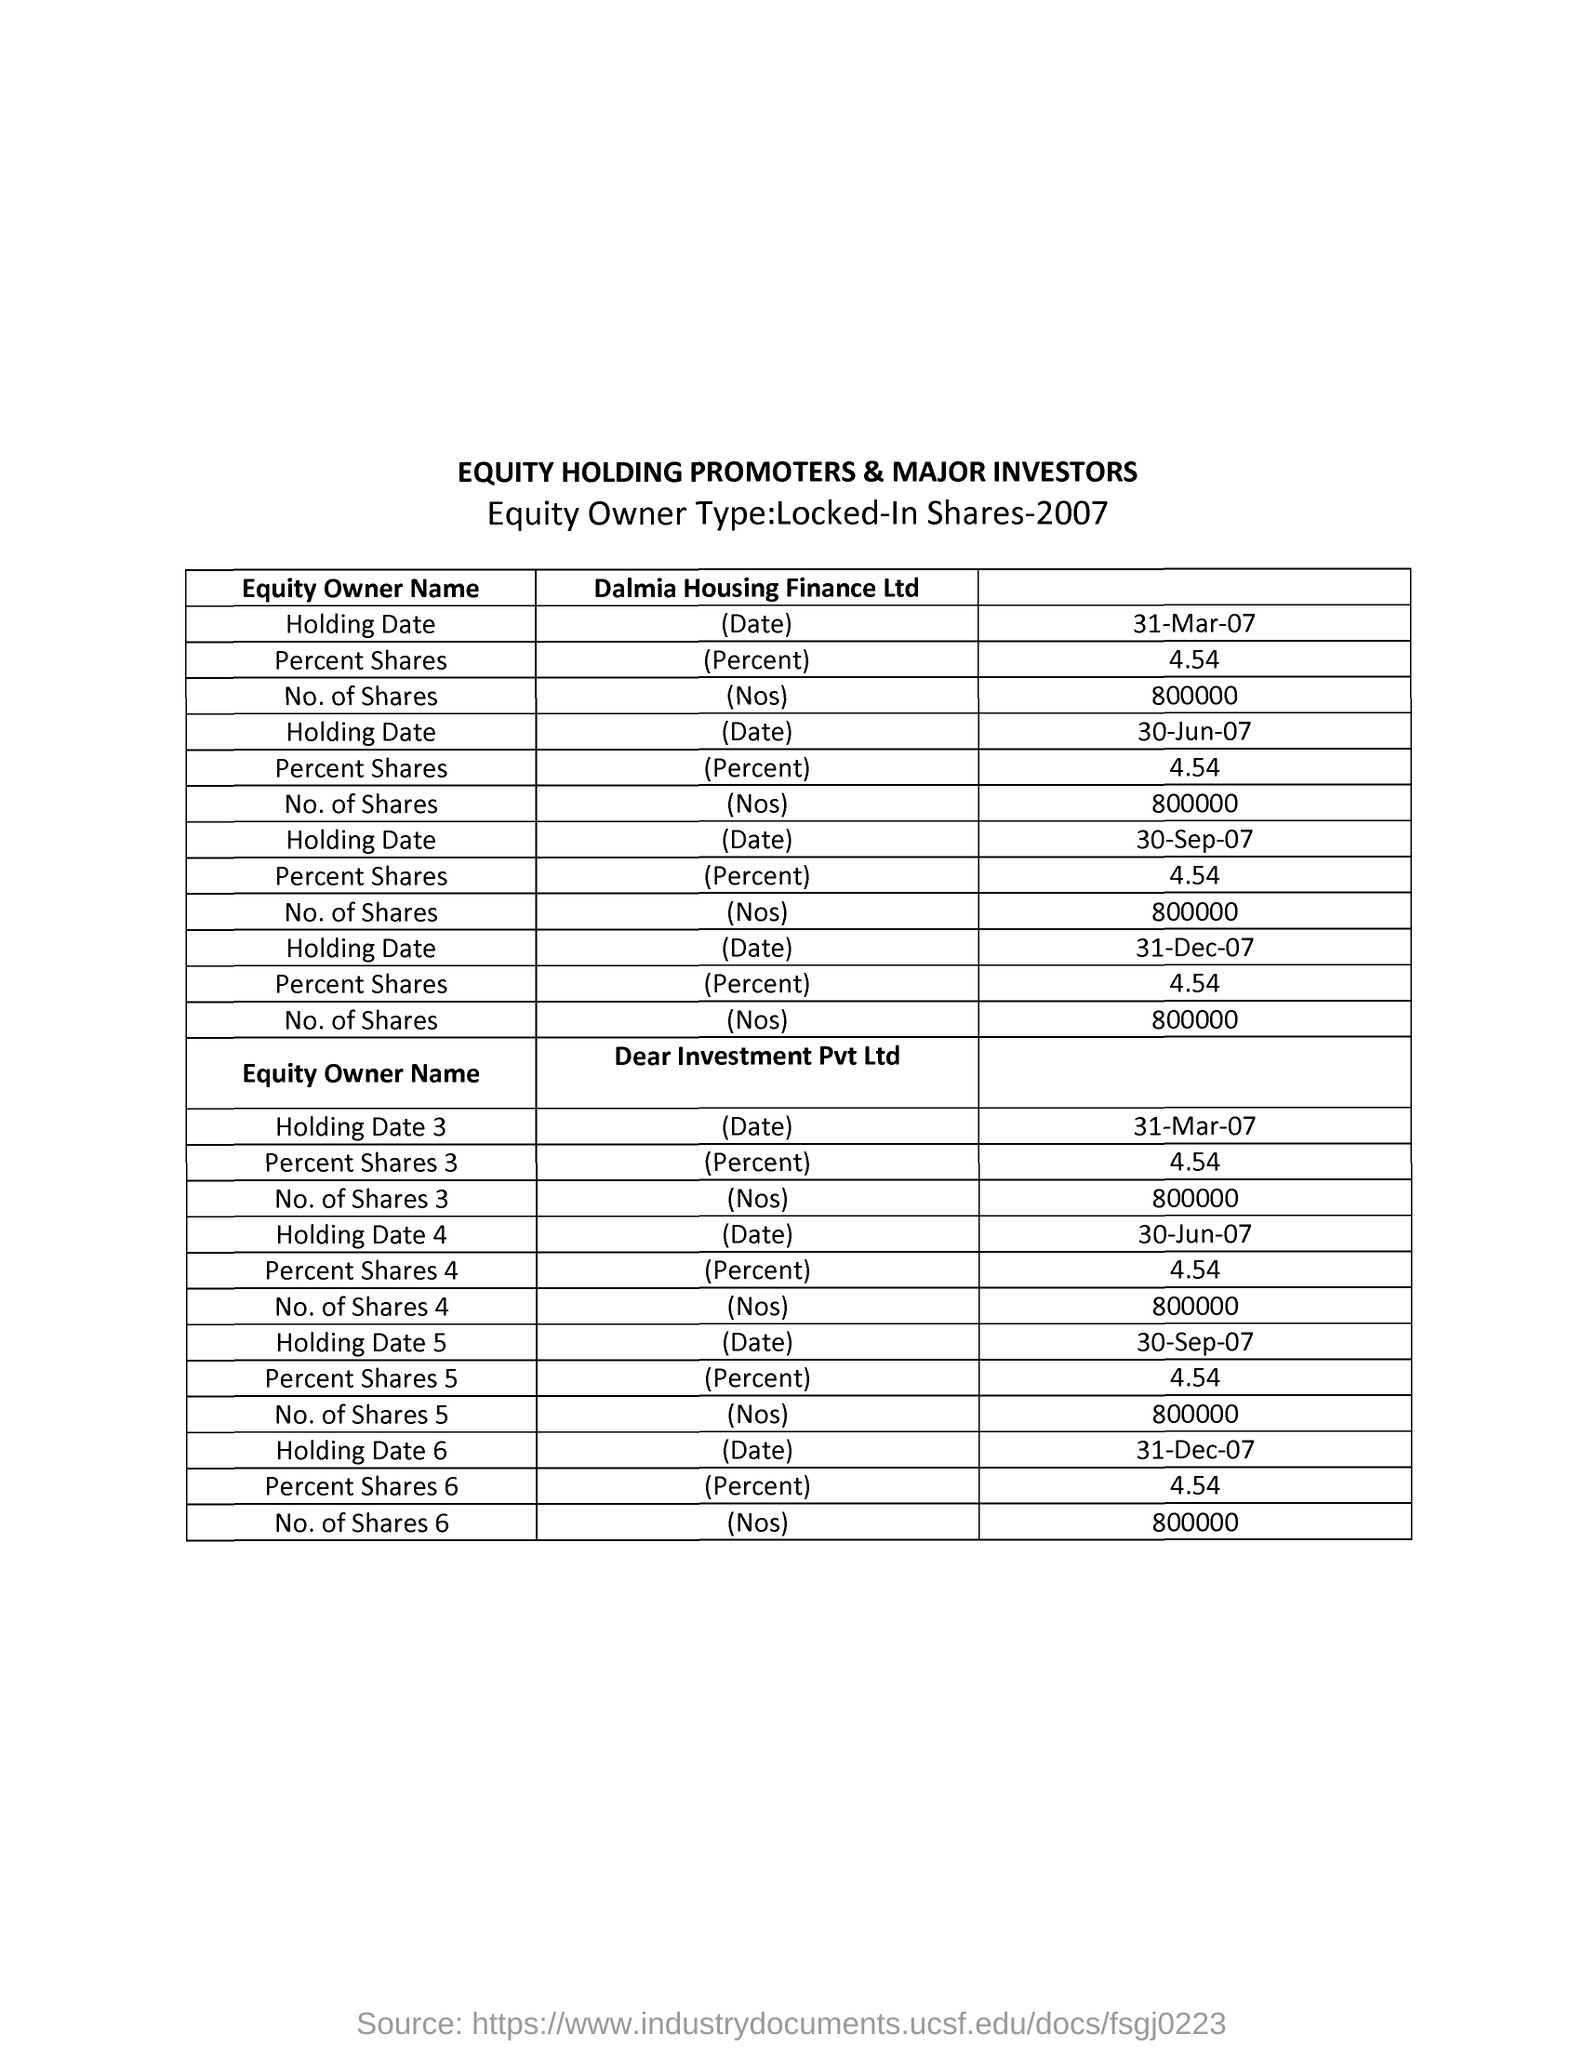Give some essential details in this illustration. The first field entered under "Equity Owner Name" in the table of Dalmia Housing Finance Ltd is "Holding Date. The first field entered under "Equity Owner Name" in the table of Dear Investment Pvt Ltd is 'Holding Date', with the first entry being '3.'. The value of the Percent Shares given to all equity owners is 4.54. The heading for the second column of the first table is 'Dalmia Housing Finance Ltd.'. The table provided is titled 'EQUITY HOLDING PROMOTERS & MAJOR INVESTORS', with a heading in capital letters. 